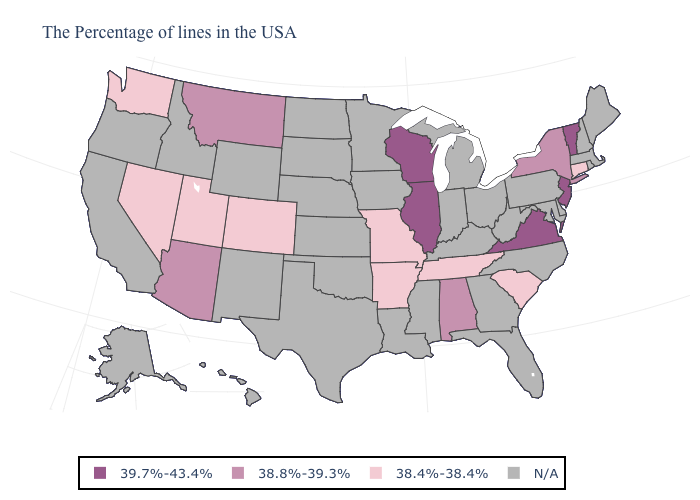Name the states that have a value in the range 39.7%-43.4%?
Write a very short answer. Vermont, New Jersey, Virginia, Wisconsin, Illinois. What is the value of Iowa?
Answer briefly. N/A. Name the states that have a value in the range N/A?
Keep it brief. Maine, Massachusetts, Rhode Island, New Hampshire, Delaware, Maryland, Pennsylvania, North Carolina, West Virginia, Ohio, Florida, Georgia, Michigan, Kentucky, Indiana, Mississippi, Louisiana, Minnesota, Iowa, Kansas, Nebraska, Oklahoma, Texas, South Dakota, North Dakota, Wyoming, New Mexico, Idaho, California, Oregon, Alaska, Hawaii. Does the first symbol in the legend represent the smallest category?
Concise answer only. No. Which states hav the highest value in the West?
Answer briefly. Montana, Arizona. Does the map have missing data?
Short answer required. Yes. Does New York have the highest value in the Northeast?
Answer briefly. No. What is the value of Kansas?
Concise answer only. N/A. What is the lowest value in the West?
Keep it brief. 38.4%-38.4%. Does Nevada have the lowest value in the West?
Quick response, please. Yes. What is the value of New Hampshire?
Keep it brief. N/A. Among the states that border California , which have the highest value?
Quick response, please. Arizona. How many symbols are there in the legend?
Short answer required. 4. 